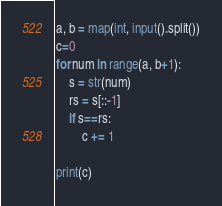<code> <loc_0><loc_0><loc_500><loc_500><_Python_>a, b = map(int, input().split())
c=0
for num in range(a, b+1):
    s = str(num)
    rs = s[::-1]
    if s==rs:
        c += 1

print(c)</code> 